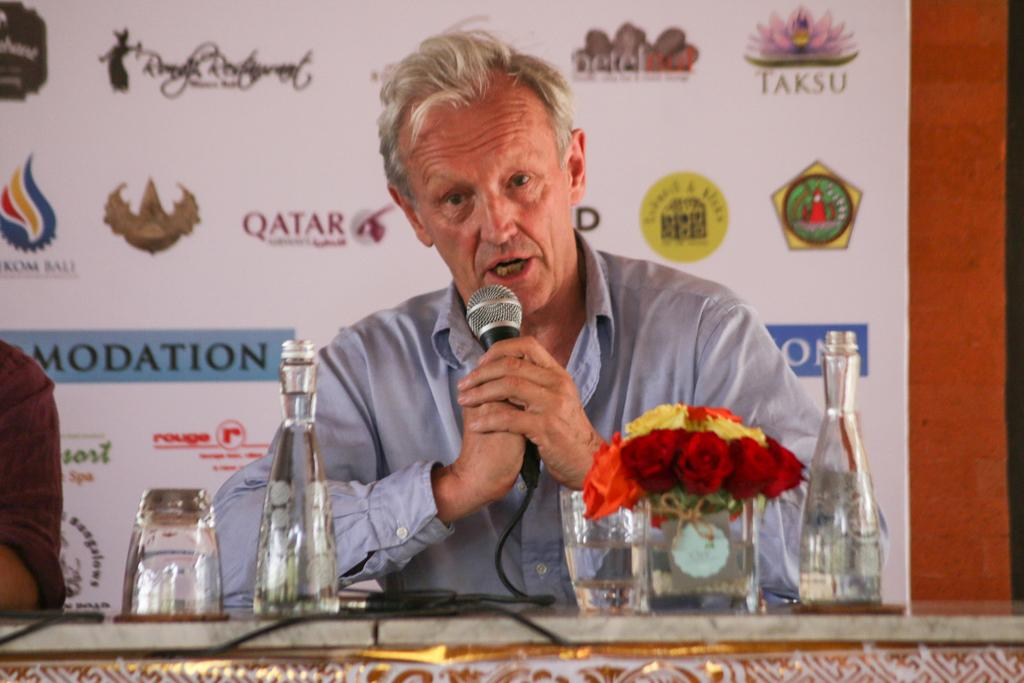<image>
Summarize the visual content of the image. Man speaking into a microphone with a brand board behind him with TAKSU, QATAR, KOMA BALI and other brands displayed. 